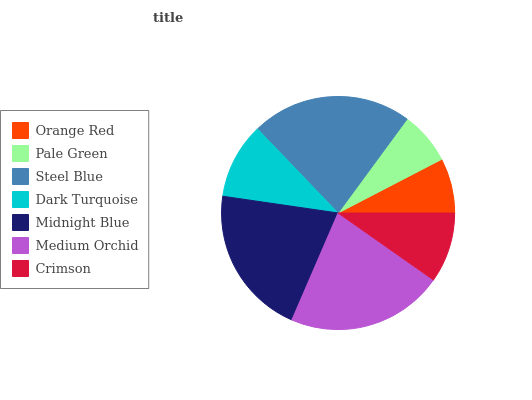Is Pale Green the minimum?
Answer yes or no. Yes. Is Steel Blue the maximum?
Answer yes or no. Yes. Is Steel Blue the minimum?
Answer yes or no. No. Is Pale Green the maximum?
Answer yes or no. No. Is Steel Blue greater than Pale Green?
Answer yes or no. Yes. Is Pale Green less than Steel Blue?
Answer yes or no. Yes. Is Pale Green greater than Steel Blue?
Answer yes or no. No. Is Steel Blue less than Pale Green?
Answer yes or no. No. Is Dark Turquoise the high median?
Answer yes or no. Yes. Is Dark Turquoise the low median?
Answer yes or no. Yes. Is Pale Green the high median?
Answer yes or no. No. Is Crimson the low median?
Answer yes or no. No. 